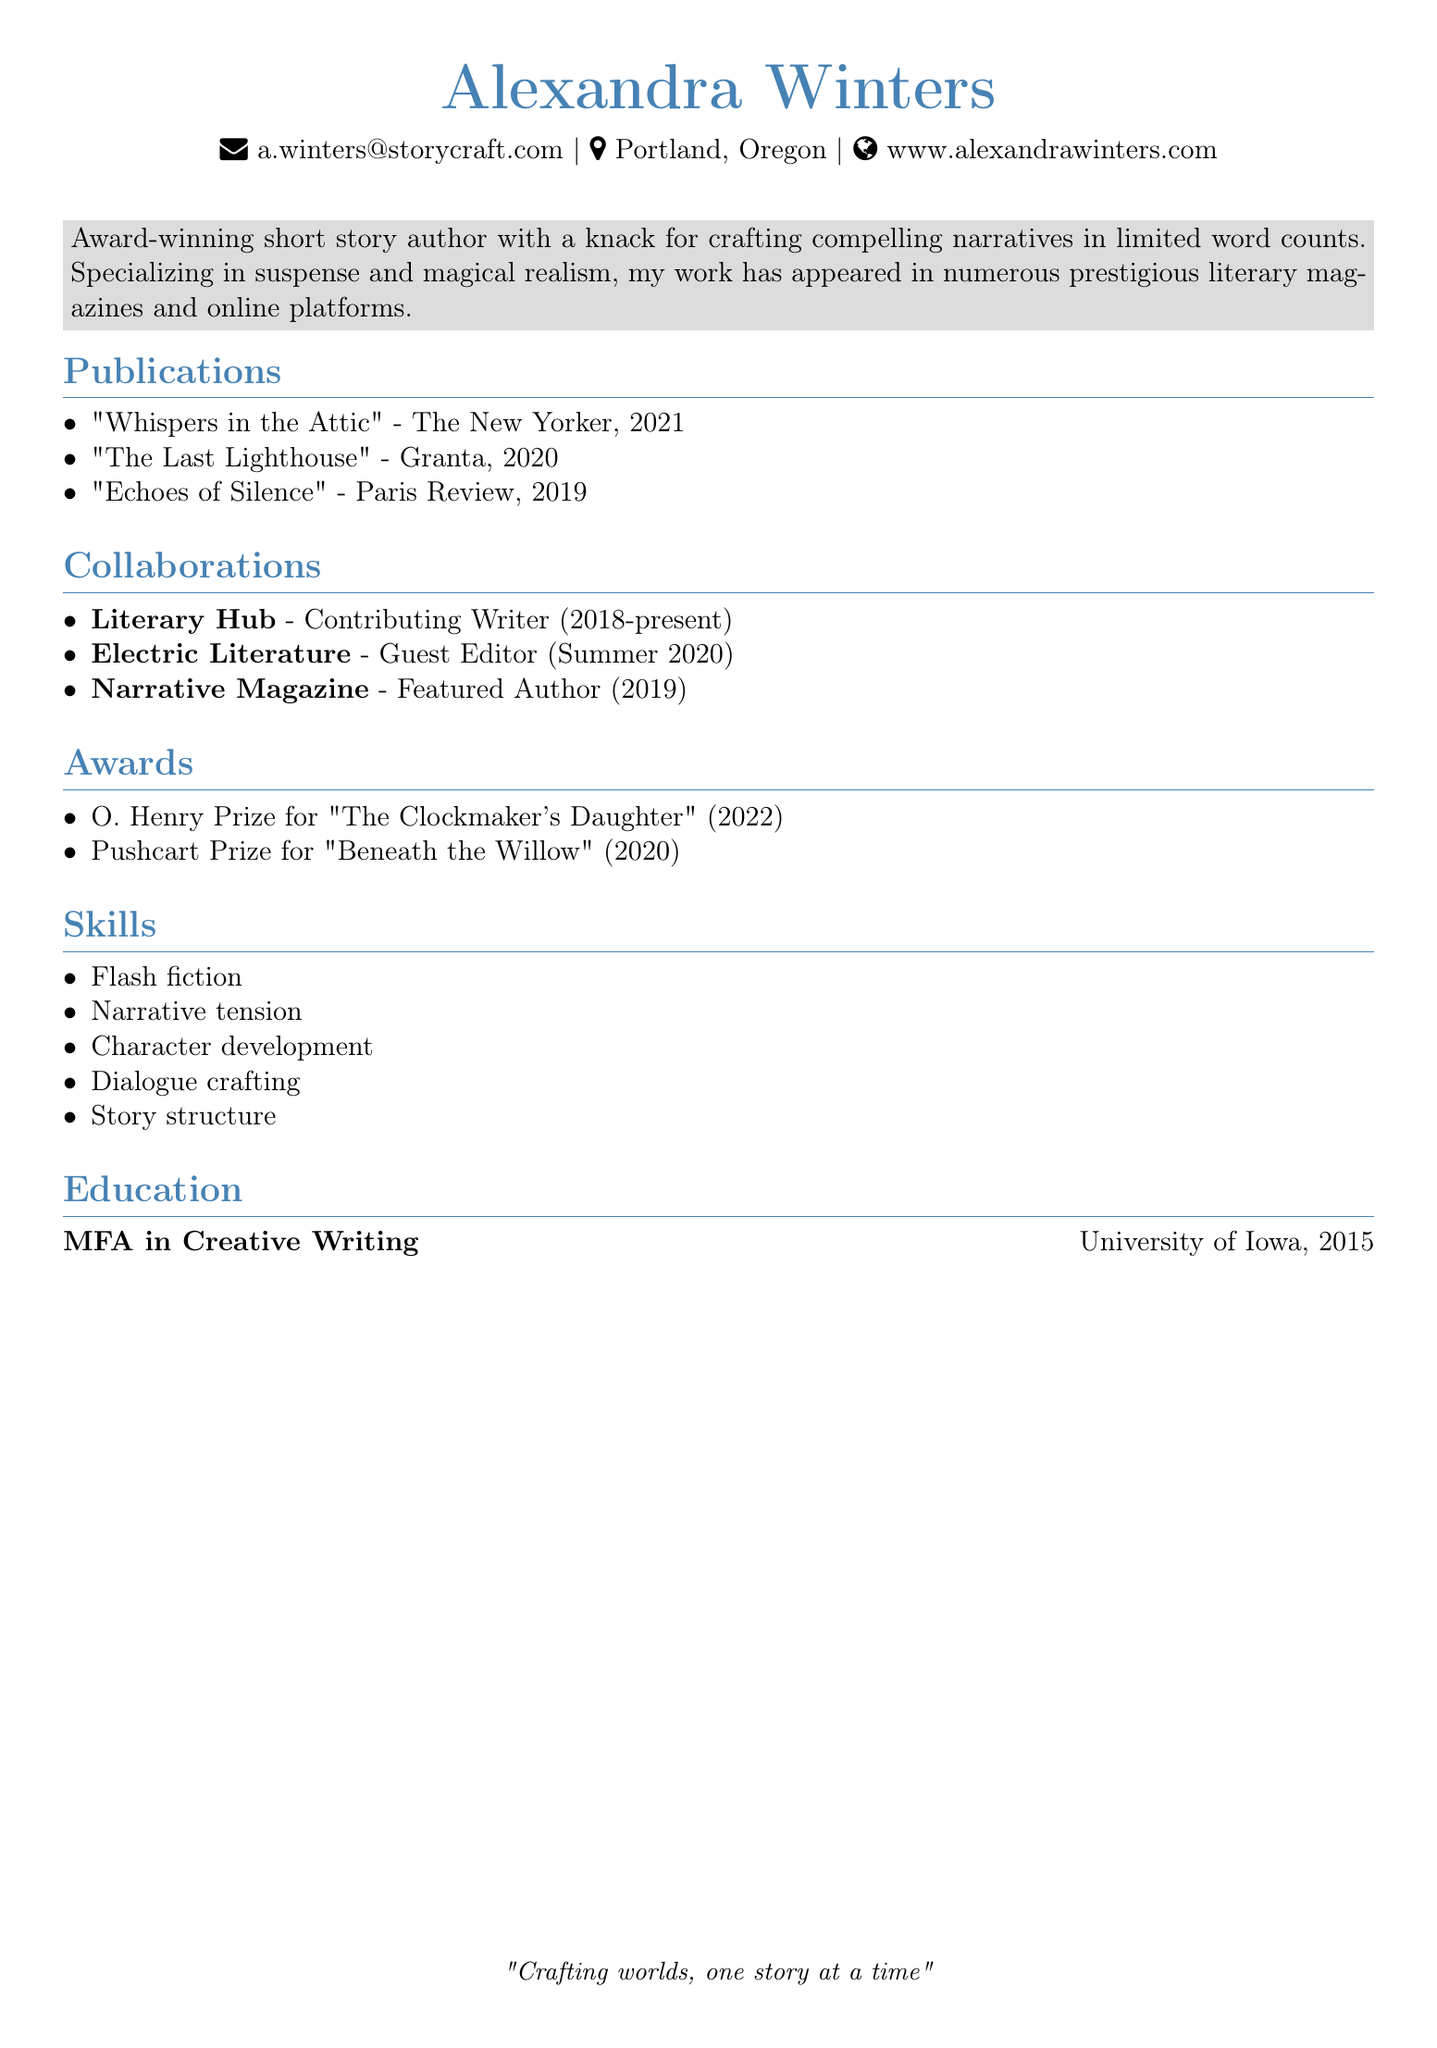What is the author's name? The author's name is prominently stated at the top of the CV.
Answer: Alexandra Winters What is the most recent publication listed? The most recent publication is the last item in the publications section.
Answer: "Whispers in the Attic" Which award did Alexandra Winters win in 2022? The award section lists the O. Henry Prize and the year indicates it was won in 2022.
Answer: O. Henry Prize How long has Alexandra been a contributing writer for Literary Hub? The duration listed shows the start year and since it is currently 2023, the calculation leads to 5 years.
Answer: 5 years Where did Alexandra obtain her MFA? The education section specifies the institution where the degree was obtained.
Answer: University of Iowa What genre does Alexandra specialize in? The summary section describes her specialties, including suspense and magical realism.
Answer: Suspense and magical realism In which year was "Beneath the Willow" awarded the Pushcart Prize? The awards section specifies the year when the award was received.
Answer: 2020 What role did Alexandra have at Electric Literature in Summer 2020? The collaborations section identifies her position during that time.
Answer: Guest Editor 